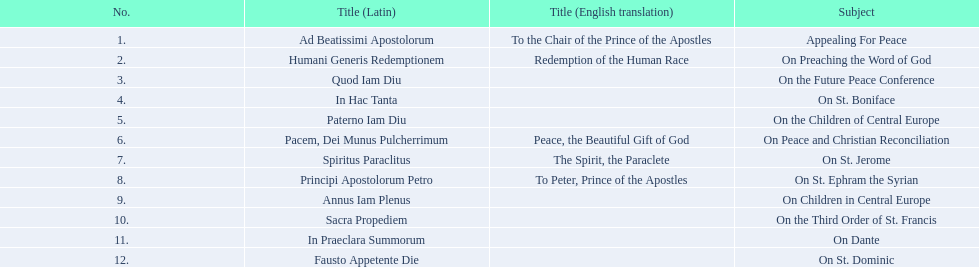What are all the subjects? Appealing For Peace, On Preaching the Word of God, On the Future Peace Conference, On St. Boniface, On the Children of Central Europe, On Peace and Christian Reconciliation, On St. Jerome, On St. Ephram the Syrian, On Children in Central Europe, On the Third Order of St. Francis, On Dante, On St. Dominic. What are their dates? 1 November 1914, 15 June 1917, 1 December 1918, 14 May 1919, 24 November 1919, 23 May 1920, 15 September 1920, 5 October 1920, 1 December 1920, 6 January 1921, 30 April 1921, 29 June 1921. Which subject's date belongs to 23 may 1920? On Peace and Christian Reconciliation. 